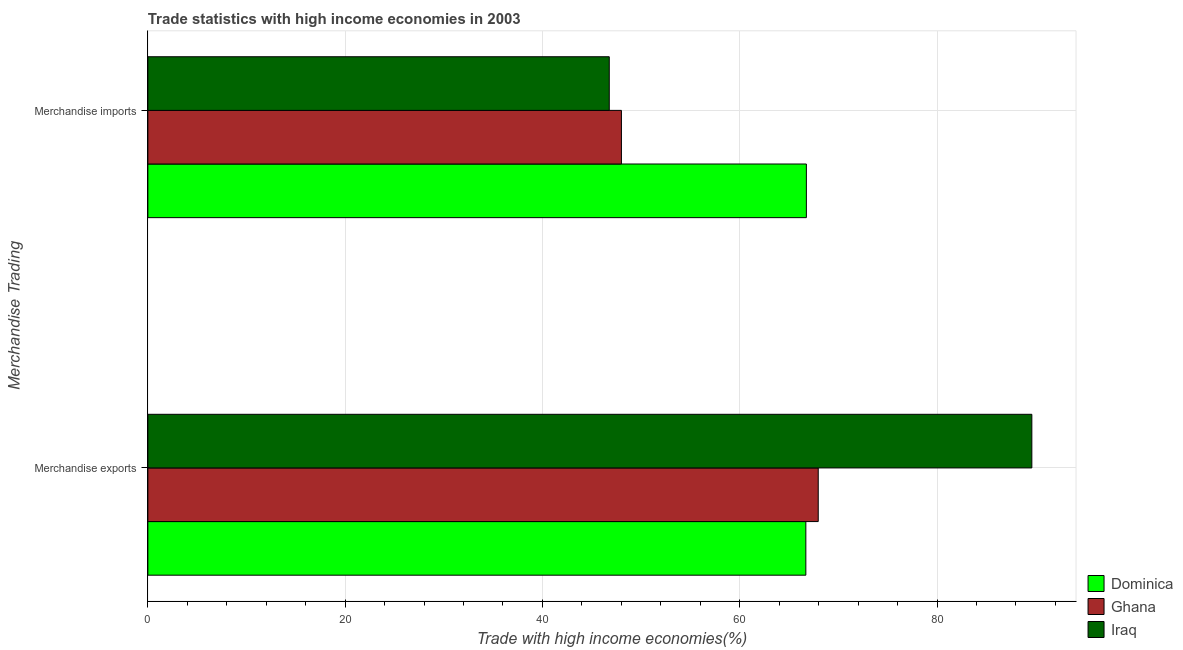How many different coloured bars are there?
Provide a short and direct response. 3. How many bars are there on the 2nd tick from the top?
Provide a succinct answer. 3. What is the merchandise imports in Iraq?
Provide a short and direct response. 46.78. Across all countries, what is the maximum merchandise imports?
Keep it short and to the point. 66.76. Across all countries, what is the minimum merchandise imports?
Provide a short and direct response. 46.78. In which country was the merchandise exports maximum?
Keep it short and to the point. Iraq. In which country was the merchandise exports minimum?
Ensure brevity in your answer.  Dominica. What is the total merchandise imports in the graph?
Give a very brief answer. 161.54. What is the difference between the merchandise imports in Iraq and that in Ghana?
Ensure brevity in your answer.  -1.23. What is the difference between the merchandise exports in Ghana and the merchandise imports in Dominica?
Your answer should be very brief. 1.2. What is the average merchandise imports per country?
Your answer should be very brief. 53.85. What is the difference between the merchandise imports and merchandise exports in Ghana?
Your answer should be compact. -19.95. In how many countries, is the merchandise imports greater than 84 %?
Your response must be concise. 0. What is the ratio of the merchandise exports in Iraq to that in Ghana?
Your answer should be compact. 1.32. Is the merchandise exports in Iraq less than that in Dominica?
Offer a terse response. No. In how many countries, is the merchandise exports greater than the average merchandise exports taken over all countries?
Provide a short and direct response. 1. What does the 3rd bar from the top in Merchandise imports represents?
Your answer should be very brief. Dominica. What does the 1st bar from the bottom in Merchandise imports represents?
Your response must be concise. Dominica. What is the difference between two consecutive major ticks on the X-axis?
Keep it short and to the point. 20. Does the graph contain any zero values?
Give a very brief answer. No. Does the graph contain grids?
Offer a terse response. Yes. Where does the legend appear in the graph?
Make the answer very short. Bottom right. How many legend labels are there?
Ensure brevity in your answer.  3. What is the title of the graph?
Your answer should be very brief. Trade statistics with high income economies in 2003. Does "Europe(developing only)" appear as one of the legend labels in the graph?
Your answer should be very brief. No. What is the label or title of the X-axis?
Provide a short and direct response. Trade with high income economies(%). What is the label or title of the Y-axis?
Keep it short and to the point. Merchandise Trading. What is the Trade with high income economies(%) of Dominica in Merchandise exports?
Ensure brevity in your answer.  66.7. What is the Trade with high income economies(%) in Ghana in Merchandise exports?
Ensure brevity in your answer.  67.96. What is the Trade with high income economies(%) in Iraq in Merchandise exports?
Your response must be concise. 89.62. What is the Trade with high income economies(%) of Dominica in Merchandise imports?
Provide a short and direct response. 66.76. What is the Trade with high income economies(%) of Ghana in Merchandise imports?
Offer a very short reply. 48.01. What is the Trade with high income economies(%) in Iraq in Merchandise imports?
Your response must be concise. 46.78. Across all Merchandise Trading, what is the maximum Trade with high income economies(%) of Dominica?
Make the answer very short. 66.76. Across all Merchandise Trading, what is the maximum Trade with high income economies(%) of Ghana?
Ensure brevity in your answer.  67.96. Across all Merchandise Trading, what is the maximum Trade with high income economies(%) of Iraq?
Your response must be concise. 89.62. Across all Merchandise Trading, what is the minimum Trade with high income economies(%) of Dominica?
Your answer should be very brief. 66.7. Across all Merchandise Trading, what is the minimum Trade with high income economies(%) in Ghana?
Provide a short and direct response. 48.01. Across all Merchandise Trading, what is the minimum Trade with high income economies(%) of Iraq?
Make the answer very short. 46.78. What is the total Trade with high income economies(%) in Dominica in the graph?
Ensure brevity in your answer.  133.46. What is the total Trade with high income economies(%) of Ghana in the graph?
Keep it short and to the point. 115.97. What is the total Trade with high income economies(%) in Iraq in the graph?
Ensure brevity in your answer.  136.39. What is the difference between the Trade with high income economies(%) in Dominica in Merchandise exports and that in Merchandise imports?
Ensure brevity in your answer.  -0.05. What is the difference between the Trade with high income economies(%) in Ghana in Merchandise exports and that in Merchandise imports?
Keep it short and to the point. 19.95. What is the difference between the Trade with high income economies(%) in Iraq in Merchandise exports and that in Merchandise imports?
Make the answer very short. 42.84. What is the difference between the Trade with high income economies(%) in Dominica in Merchandise exports and the Trade with high income economies(%) in Ghana in Merchandise imports?
Keep it short and to the point. 18.7. What is the difference between the Trade with high income economies(%) in Dominica in Merchandise exports and the Trade with high income economies(%) in Iraq in Merchandise imports?
Give a very brief answer. 19.93. What is the difference between the Trade with high income economies(%) in Ghana in Merchandise exports and the Trade with high income economies(%) in Iraq in Merchandise imports?
Your answer should be compact. 21.18. What is the average Trade with high income economies(%) in Dominica per Merchandise Trading?
Your response must be concise. 66.73. What is the average Trade with high income economies(%) in Ghana per Merchandise Trading?
Offer a terse response. 57.98. What is the average Trade with high income economies(%) of Iraq per Merchandise Trading?
Make the answer very short. 68.2. What is the difference between the Trade with high income economies(%) of Dominica and Trade with high income economies(%) of Ghana in Merchandise exports?
Your answer should be compact. -1.26. What is the difference between the Trade with high income economies(%) in Dominica and Trade with high income economies(%) in Iraq in Merchandise exports?
Your answer should be compact. -22.91. What is the difference between the Trade with high income economies(%) of Ghana and Trade with high income economies(%) of Iraq in Merchandise exports?
Offer a terse response. -21.66. What is the difference between the Trade with high income economies(%) of Dominica and Trade with high income economies(%) of Ghana in Merchandise imports?
Ensure brevity in your answer.  18.75. What is the difference between the Trade with high income economies(%) of Dominica and Trade with high income economies(%) of Iraq in Merchandise imports?
Provide a succinct answer. 19.98. What is the difference between the Trade with high income economies(%) of Ghana and Trade with high income economies(%) of Iraq in Merchandise imports?
Your answer should be compact. 1.23. What is the ratio of the Trade with high income economies(%) of Ghana in Merchandise exports to that in Merchandise imports?
Offer a very short reply. 1.42. What is the ratio of the Trade with high income economies(%) in Iraq in Merchandise exports to that in Merchandise imports?
Offer a terse response. 1.92. What is the difference between the highest and the second highest Trade with high income economies(%) in Dominica?
Offer a terse response. 0.05. What is the difference between the highest and the second highest Trade with high income economies(%) in Ghana?
Provide a short and direct response. 19.95. What is the difference between the highest and the second highest Trade with high income economies(%) of Iraq?
Offer a terse response. 42.84. What is the difference between the highest and the lowest Trade with high income economies(%) of Dominica?
Offer a very short reply. 0.05. What is the difference between the highest and the lowest Trade with high income economies(%) of Ghana?
Your answer should be compact. 19.95. What is the difference between the highest and the lowest Trade with high income economies(%) in Iraq?
Provide a succinct answer. 42.84. 